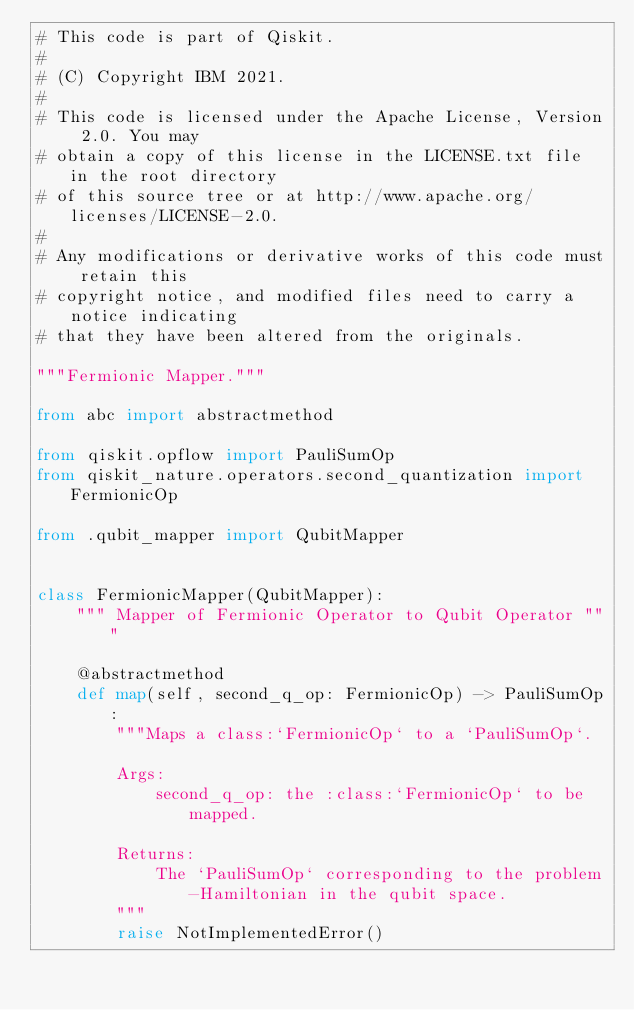<code> <loc_0><loc_0><loc_500><loc_500><_Python_># This code is part of Qiskit.
#
# (C) Copyright IBM 2021.
#
# This code is licensed under the Apache License, Version 2.0. You may
# obtain a copy of this license in the LICENSE.txt file in the root directory
# of this source tree or at http://www.apache.org/licenses/LICENSE-2.0.
#
# Any modifications or derivative works of this code must retain this
# copyright notice, and modified files need to carry a notice indicating
# that they have been altered from the originals.

"""Fermionic Mapper."""

from abc import abstractmethod

from qiskit.opflow import PauliSumOp
from qiskit_nature.operators.second_quantization import FermionicOp

from .qubit_mapper import QubitMapper


class FermionicMapper(QubitMapper):
    """ Mapper of Fermionic Operator to Qubit Operator """

    @abstractmethod
    def map(self, second_q_op: FermionicOp) -> PauliSumOp:
        """Maps a class:`FermionicOp` to a `PauliSumOp`.

        Args:
            second_q_op: the :class:`FermionicOp` to be mapped.

        Returns:
            The `PauliSumOp` corresponding to the problem-Hamiltonian in the qubit space.
        """
        raise NotImplementedError()
</code> 